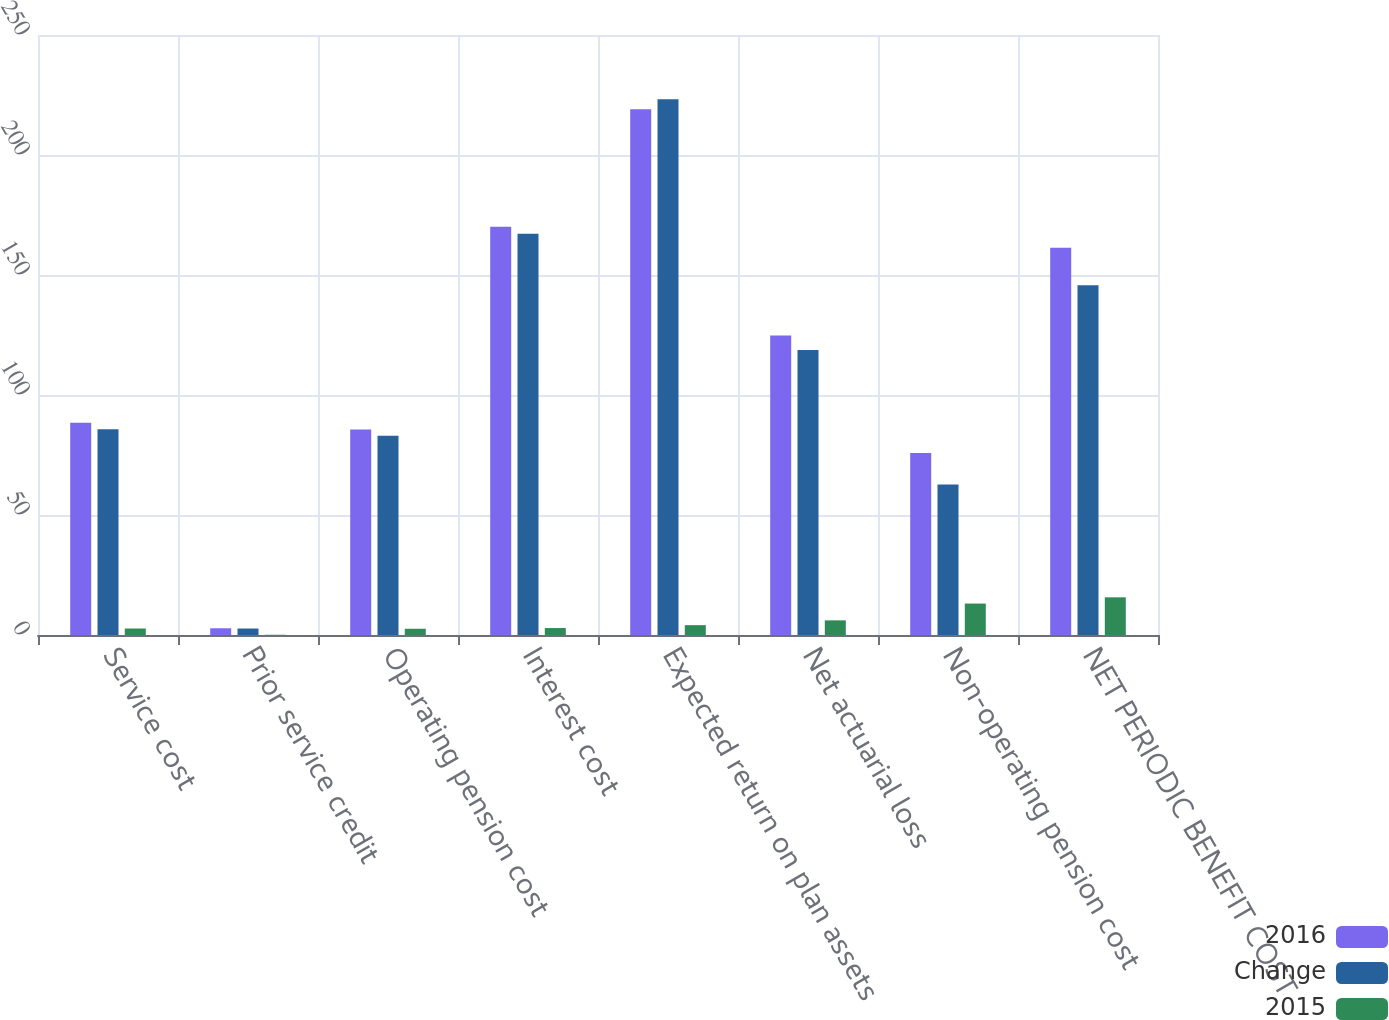Convert chart. <chart><loc_0><loc_0><loc_500><loc_500><stacked_bar_chart><ecel><fcel>Service cost<fcel>Prior service credit<fcel>Operating pension cost<fcel>Interest cost<fcel>Expected return on plan assets<fcel>Net actuarial loss<fcel>Non-operating pension cost<fcel>NET PERIODIC BENEFIT COST<nl><fcel>2016<fcel>88.4<fcel>2.8<fcel>85.6<fcel>170.1<fcel>219.1<fcel>124.8<fcel>75.8<fcel>161.4<nl><fcel>Change<fcel>85.7<fcel>2.7<fcel>83<fcel>167.2<fcel>223.2<fcel>118.7<fcel>62.7<fcel>145.7<nl><fcel>2015<fcel>2.7<fcel>0.1<fcel>2.6<fcel>2.9<fcel>4.1<fcel>6.1<fcel>13.1<fcel>15.7<nl></chart> 